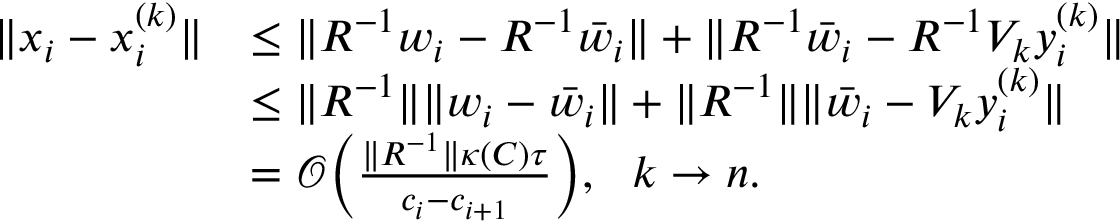<formula> <loc_0><loc_0><loc_500><loc_500>\begin{array} { r l } { \| x _ { i } - x _ { i } ^ { ( k ) } \| } & { \leq \| R ^ { - 1 } w _ { i } - R ^ { - 1 } \bar { w } _ { i } \| + \| R ^ { - 1 } \bar { w } _ { i } - R ^ { - 1 } V _ { k } y _ { i } ^ { ( k ) } \| } \\ & { \leq \| R ^ { - 1 } \| \| w _ { i } - \bar { w } _ { i } \| + \| R ^ { - 1 } \| \| \bar { w } _ { i } - V _ { k } y _ { i } ^ { ( k ) } \| } \\ & { = \mathcal { O } \left ( \frac { \| R ^ { - 1 } \| \kappa ( C ) \tau } { c _ { i } - c _ { i + 1 } } \right ) , \ \ k \to n . } \end{array}</formula> 